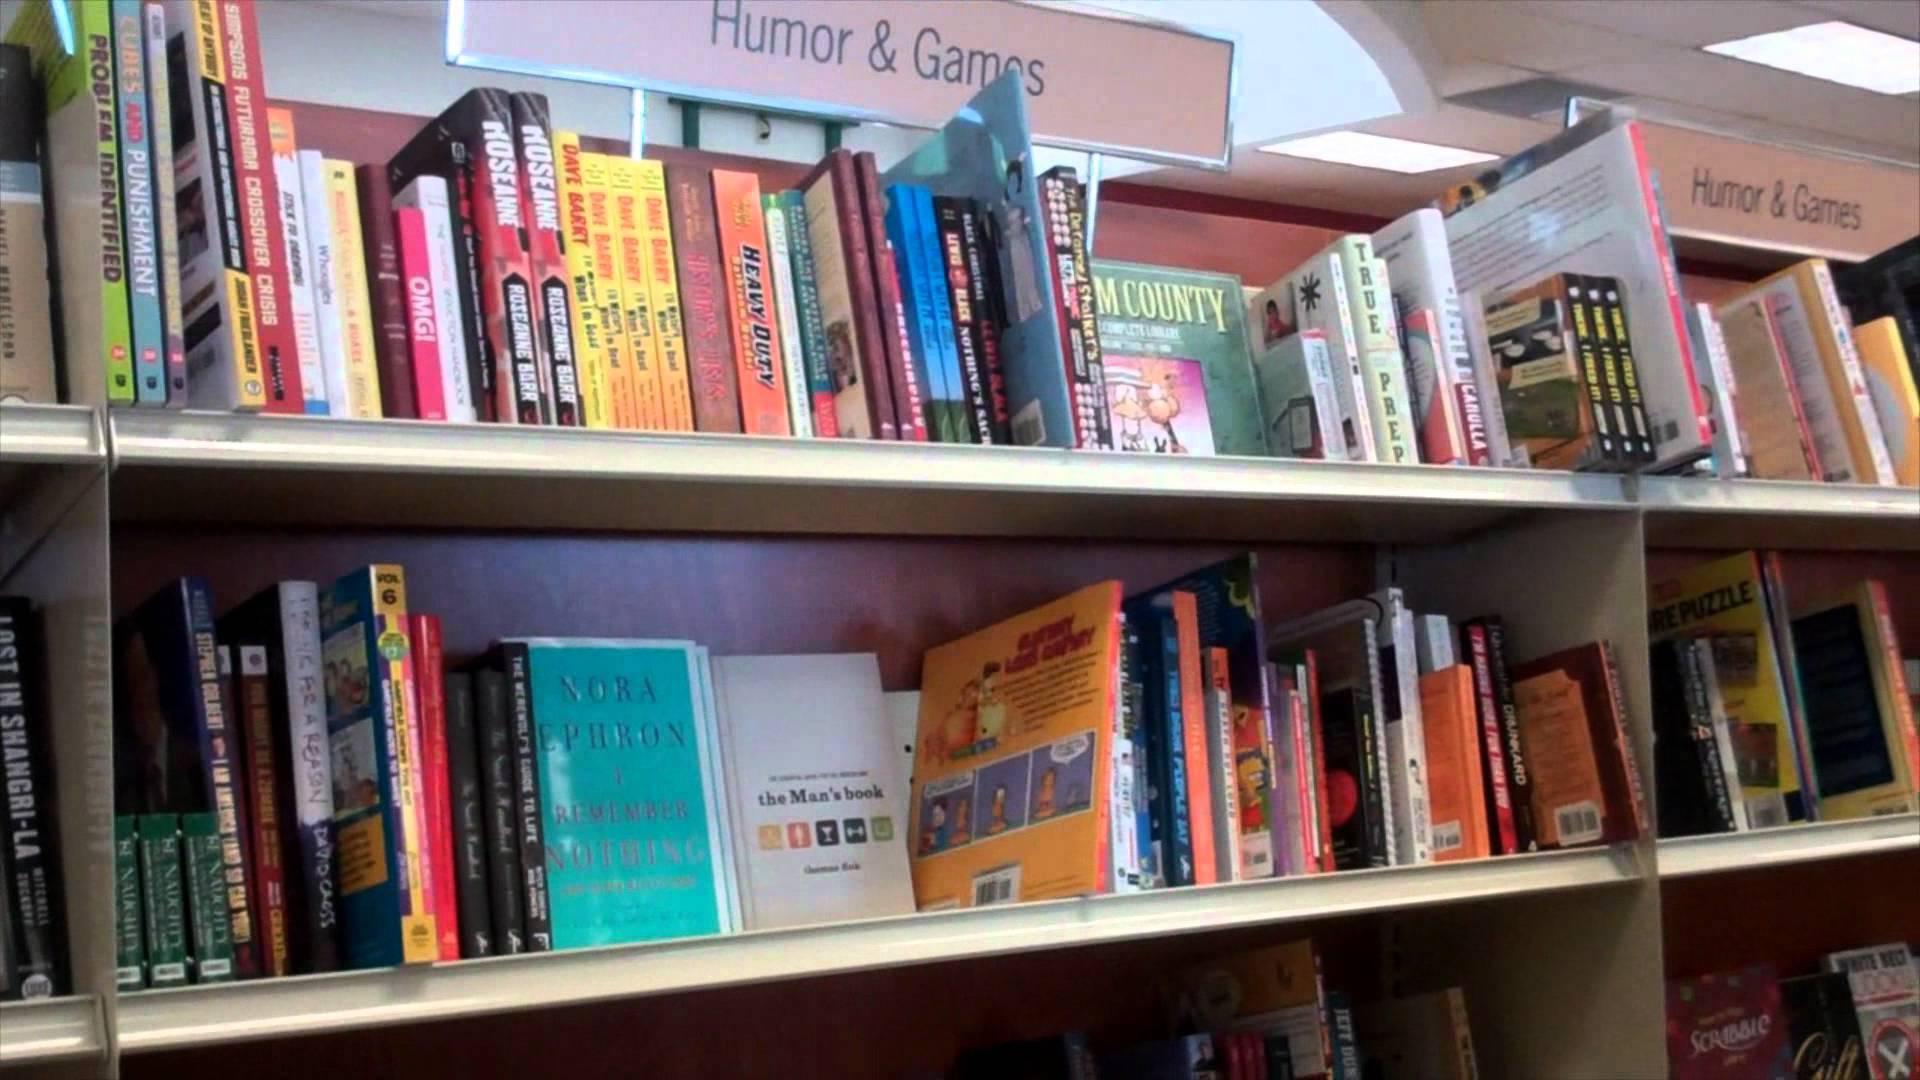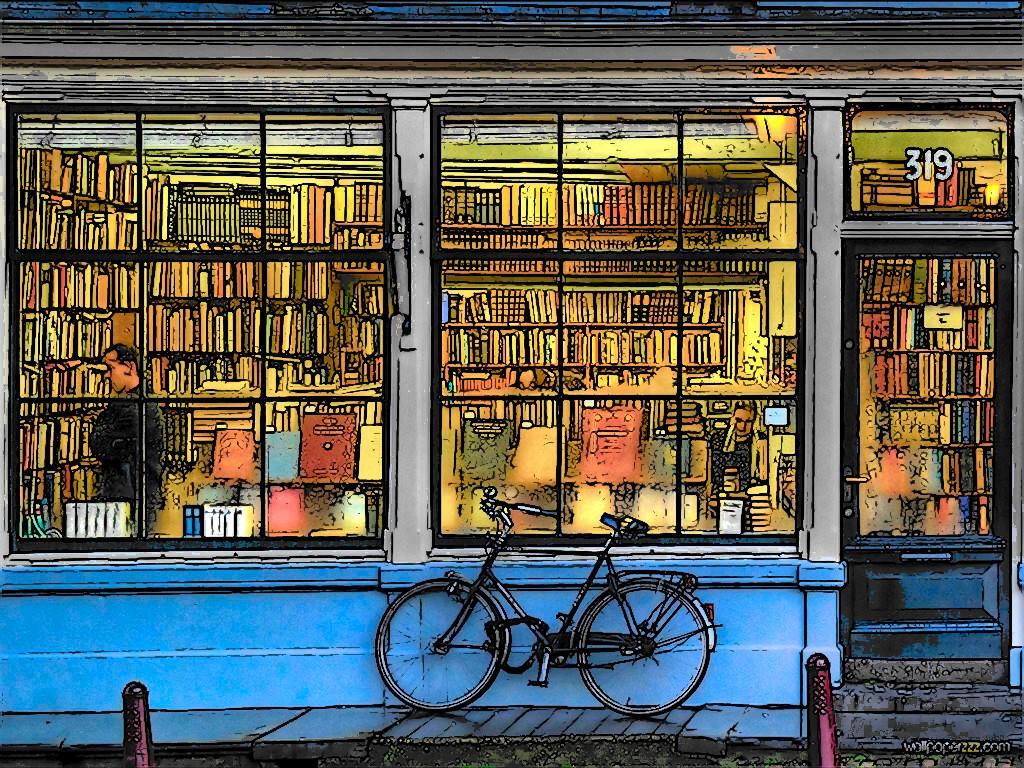The first image is the image on the left, the second image is the image on the right. Evaluate the accuracy of this statement regarding the images: "There is a person looking at a book.". Is it true? Answer yes or no. Yes. 